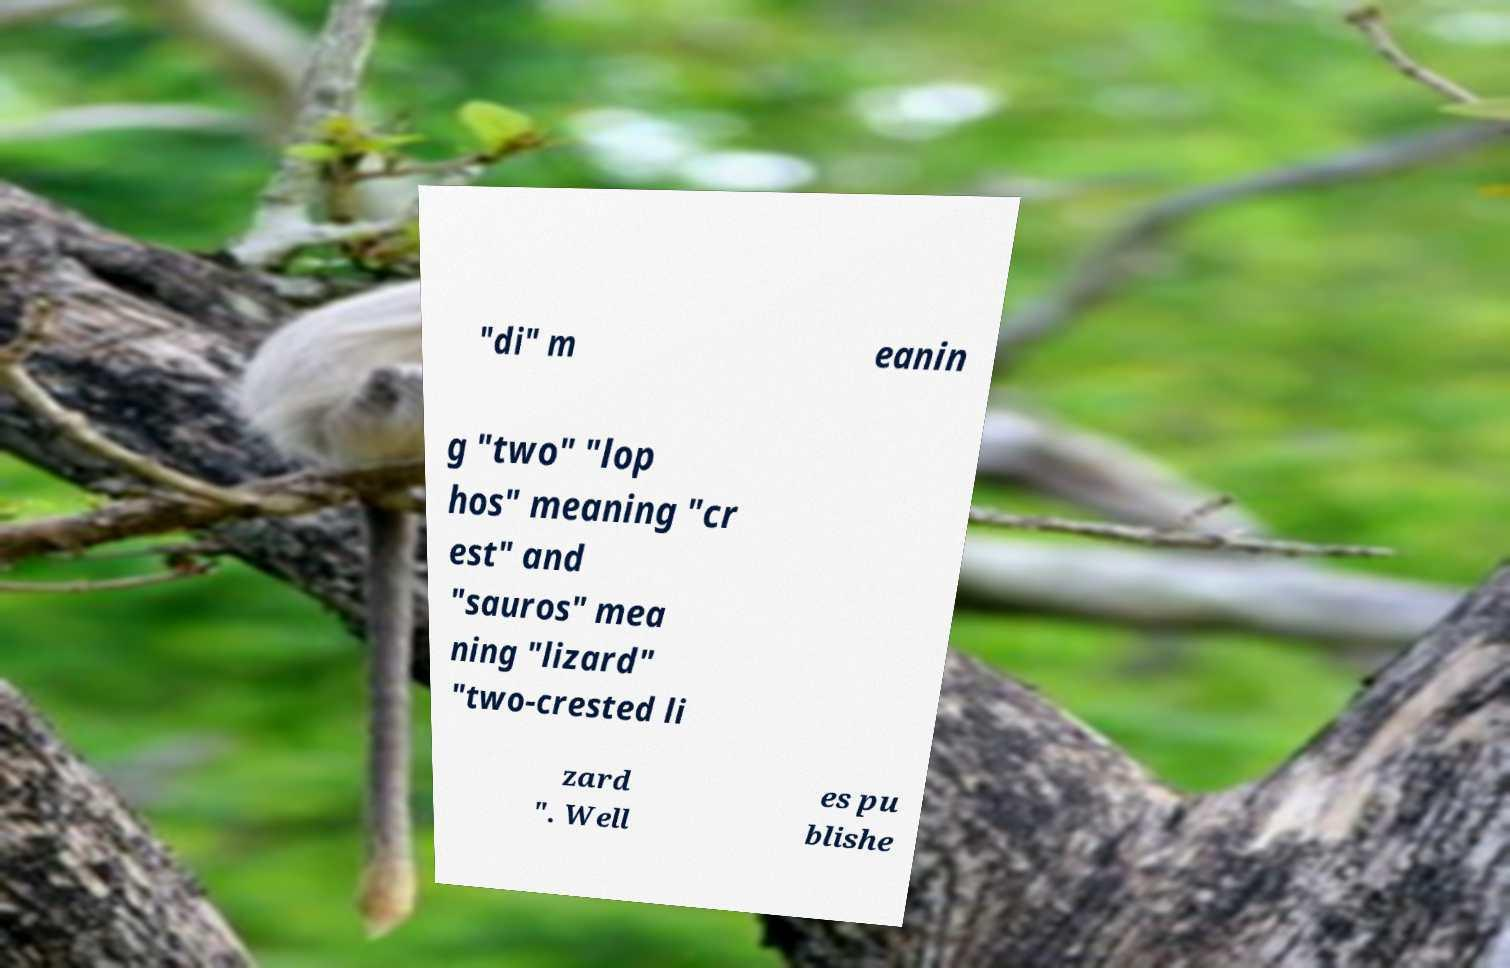Please read and relay the text visible in this image. What does it say? "di" m eanin g "two" "lop hos" meaning "cr est" and "sauros" mea ning "lizard" "two-crested li zard ". Well es pu blishe 